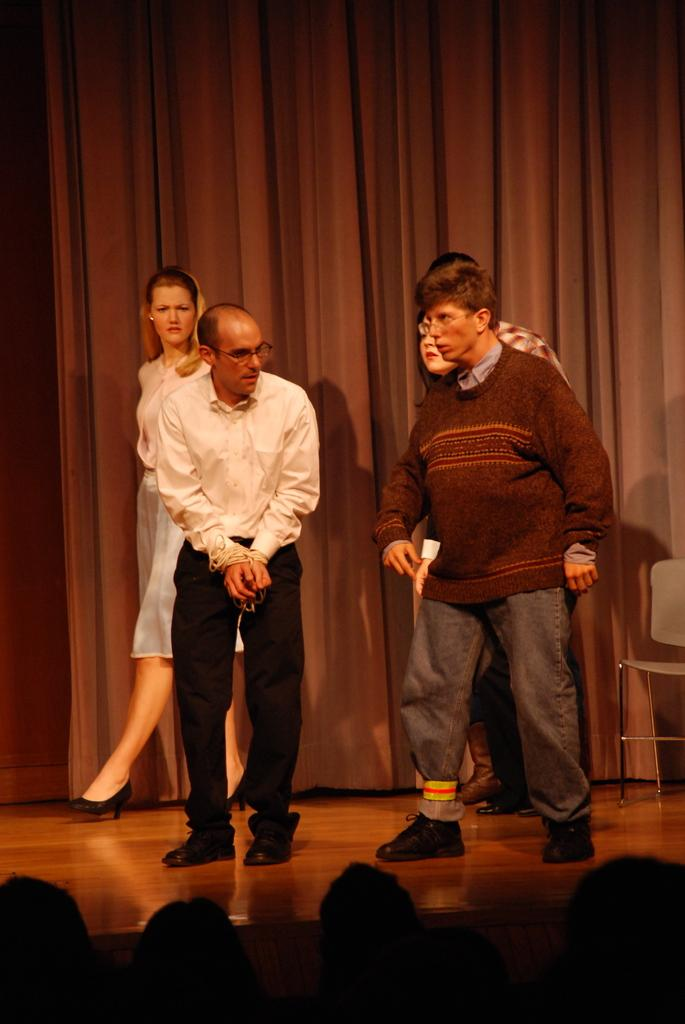How many people are on the stage in the image? There are five persons on the stage. What can be seen on the right side of the stage? There is a chair on the right side of the stage. What is visible in the background of the image? There is a curtain in the background. Can you describe the people at the bottom of the image? There are people at the bottom of the image, but their specific actions or roles cannot be determined from the provided facts. What type of marble is being smashed by the legs of the chair on the stage? There is no marble or smashing activity present in the image. The chair on the stage has legs, but they are not interacting with any marble. 